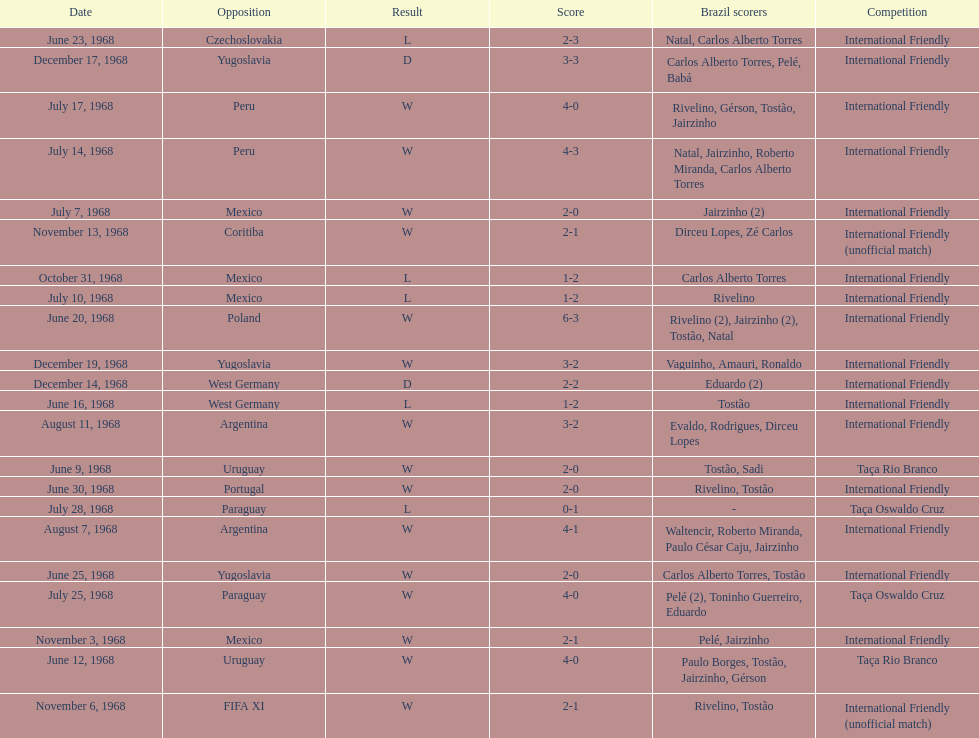Total number of wins 15. Give me the full table as a dictionary. {'header': ['Date', 'Opposition', 'Result', 'Score', 'Brazil scorers', 'Competition'], 'rows': [['June 23, 1968', 'Czechoslovakia', 'L', '2-3', 'Natal, Carlos Alberto Torres', 'International Friendly'], ['December 17, 1968', 'Yugoslavia', 'D', '3-3', 'Carlos Alberto Torres, Pelé, Babá', 'International Friendly'], ['July 17, 1968', 'Peru', 'W', '4-0', 'Rivelino, Gérson, Tostão, Jairzinho', 'International Friendly'], ['July 14, 1968', 'Peru', 'W', '4-3', 'Natal, Jairzinho, Roberto Miranda, Carlos Alberto Torres', 'International Friendly'], ['July 7, 1968', 'Mexico', 'W', '2-0', 'Jairzinho (2)', 'International Friendly'], ['November 13, 1968', 'Coritiba', 'W', '2-1', 'Dirceu Lopes, Zé Carlos', 'International Friendly (unofficial match)'], ['October 31, 1968', 'Mexico', 'L', '1-2', 'Carlos Alberto Torres', 'International Friendly'], ['July 10, 1968', 'Mexico', 'L', '1-2', 'Rivelino', 'International Friendly'], ['June 20, 1968', 'Poland', 'W', '6-3', 'Rivelino (2), Jairzinho (2), Tostão, Natal', 'International Friendly'], ['December 19, 1968', 'Yugoslavia', 'W', '3-2', 'Vaguinho, Amauri, Ronaldo', 'International Friendly'], ['December 14, 1968', 'West Germany', 'D', '2-2', 'Eduardo (2)', 'International Friendly'], ['June 16, 1968', 'West Germany', 'L', '1-2', 'Tostão', 'International Friendly'], ['August 11, 1968', 'Argentina', 'W', '3-2', 'Evaldo, Rodrigues, Dirceu Lopes', 'International Friendly'], ['June 9, 1968', 'Uruguay', 'W', '2-0', 'Tostão, Sadi', 'Taça Rio Branco'], ['June 30, 1968', 'Portugal', 'W', '2-0', 'Rivelino, Tostão', 'International Friendly'], ['July 28, 1968', 'Paraguay', 'L', '0-1', '-', 'Taça Oswaldo Cruz'], ['August 7, 1968', 'Argentina', 'W', '4-1', 'Waltencir, Roberto Miranda, Paulo César Caju, Jairzinho', 'International Friendly'], ['June 25, 1968', 'Yugoslavia', 'W', '2-0', 'Carlos Alberto Torres, Tostão', 'International Friendly'], ['July 25, 1968', 'Paraguay', 'W', '4-0', 'Pelé (2), Toninho Guerreiro, Eduardo', 'Taça Oswaldo Cruz'], ['November 3, 1968', 'Mexico', 'W', '2-1', 'Pelé, Jairzinho', 'International Friendly'], ['June 12, 1968', 'Uruguay', 'W', '4-0', 'Paulo Borges, Tostão, Jairzinho, Gérson', 'Taça Rio Branco'], ['November 6, 1968', 'FIFA XI', 'W', '2-1', 'Rivelino, Tostão', 'International Friendly (unofficial match)']]} 